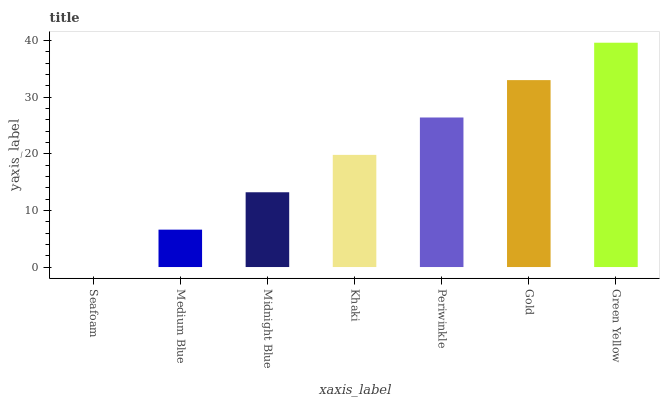Is Seafoam the minimum?
Answer yes or no. Yes. Is Green Yellow the maximum?
Answer yes or no. Yes. Is Medium Blue the minimum?
Answer yes or no. No. Is Medium Blue the maximum?
Answer yes or no. No. Is Medium Blue greater than Seafoam?
Answer yes or no. Yes. Is Seafoam less than Medium Blue?
Answer yes or no. Yes. Is Seafoam greater than Medium Blue?
Answer yes or no. No. Is Medium Blue less than Seafoam?
Answer yes or no. No. Is Khaki the high median?
Answer yes or no. Yes. Is Khaki the low median?
Answer yes or no. Yes. Is Midnight Blue the high median?
Answer yes or no. No. Is Seafoam the low median?
Answer yes or no. No. 